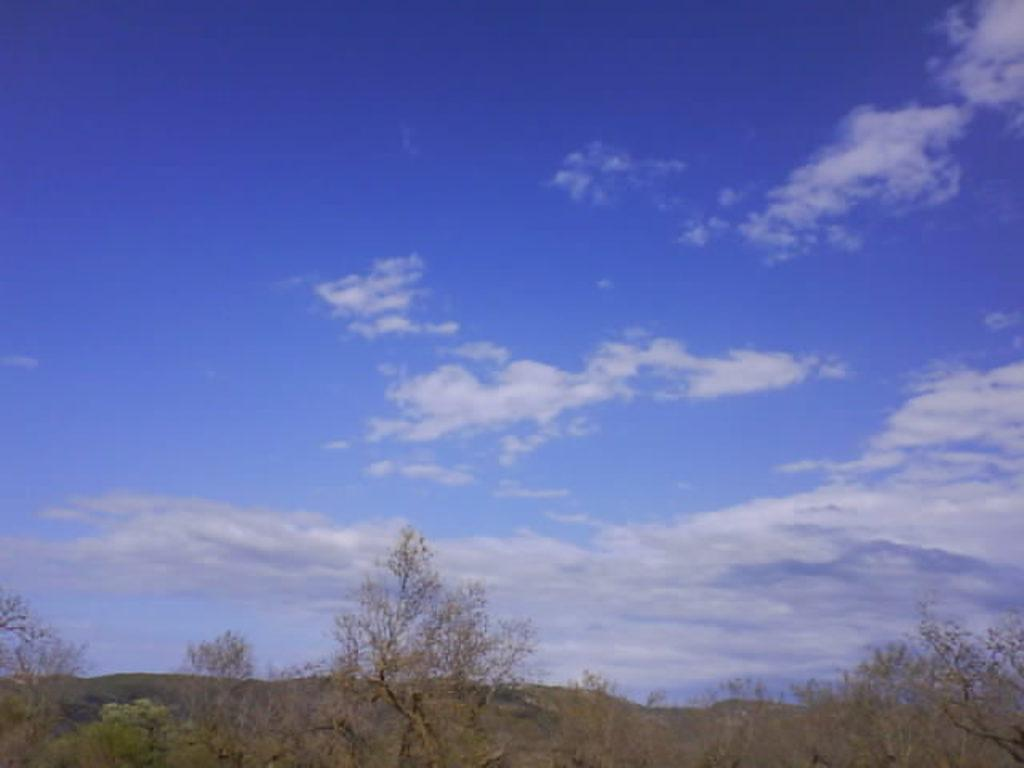What type of vegetation can be seen in the image? There are trees in the image. What part of the natural environment is visible in the image? The sky is visible in the background of the image. What language is the fireman speaking in the image? There is no fireman present in the image, so it is not possible to determine what language they might be speaking. 